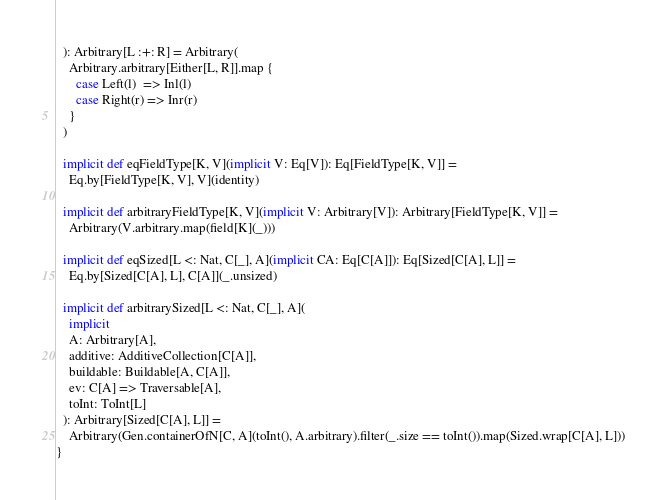Convert code to text. <code><loc_0><loc_0><loc_500><loc_500><_Scala_>  ): Arbitrary[L :+: R] = Arbitrary(
    Arbitrary.arbitrary[Either[L, R]].map {
      case Left(l)  => Inl(l)
      case Right(r) => Inr(r)
    }
  )

  implicit def eqFieldType[K, V](implicit V: Eq[V]): Eq[FieldType[K, V]] =
    Eq.by[FieldType[K, V], V](identity)

  implicit def arbitraryFieldType[K, V](implicit V: Arbitrary[V]): Arbitrary[FieldType[K, V]] =
    Arbitrary(V.arbitrary.map(field[K](_)))

  implicit def eqSized[L <: Nat, C[_], A](implicit CA: Eq[C[A]]): Eq[Sized[C[A], L]] =
    Eq.by[Sized[C[A], L], C[A]](_.unsized)

  implicit def arbitrarySized[L <: Nat, C[_], A](
    implicit
    A: Arbitrary[A],
    additive: AdditiveCollection[C[A]],
    buildable: Buildable[A, C[A]],
    ev: C[A] => Traversable[A],
    toInt: ToInt[L]
  ): Arbitrary[Sized[C[A], L]] =
    Arbitrary(Gen.containerOfN[C, A](toInt(), A.arbitrary).filter(_.size == toInt()).map(Sized.wrap[C[A], L]))
}
</code> 